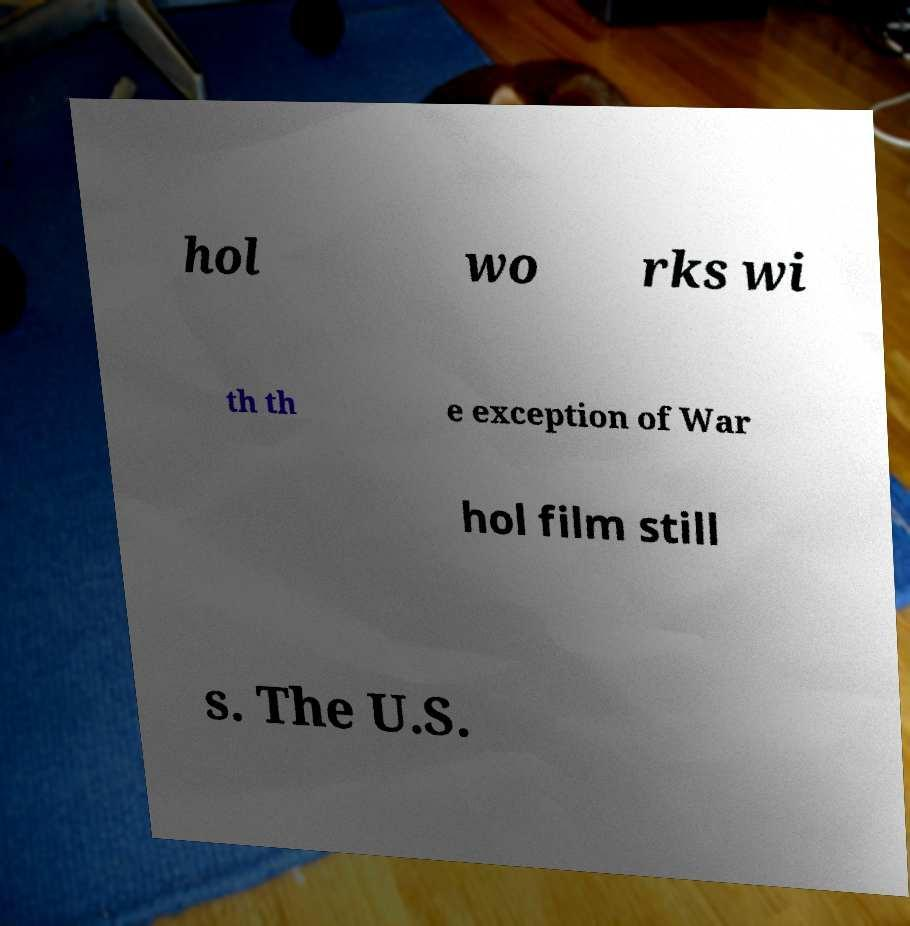Could you extract and type out the text from this image? hol wo rks wi th th e exception of War hol film still s. The U.S. 